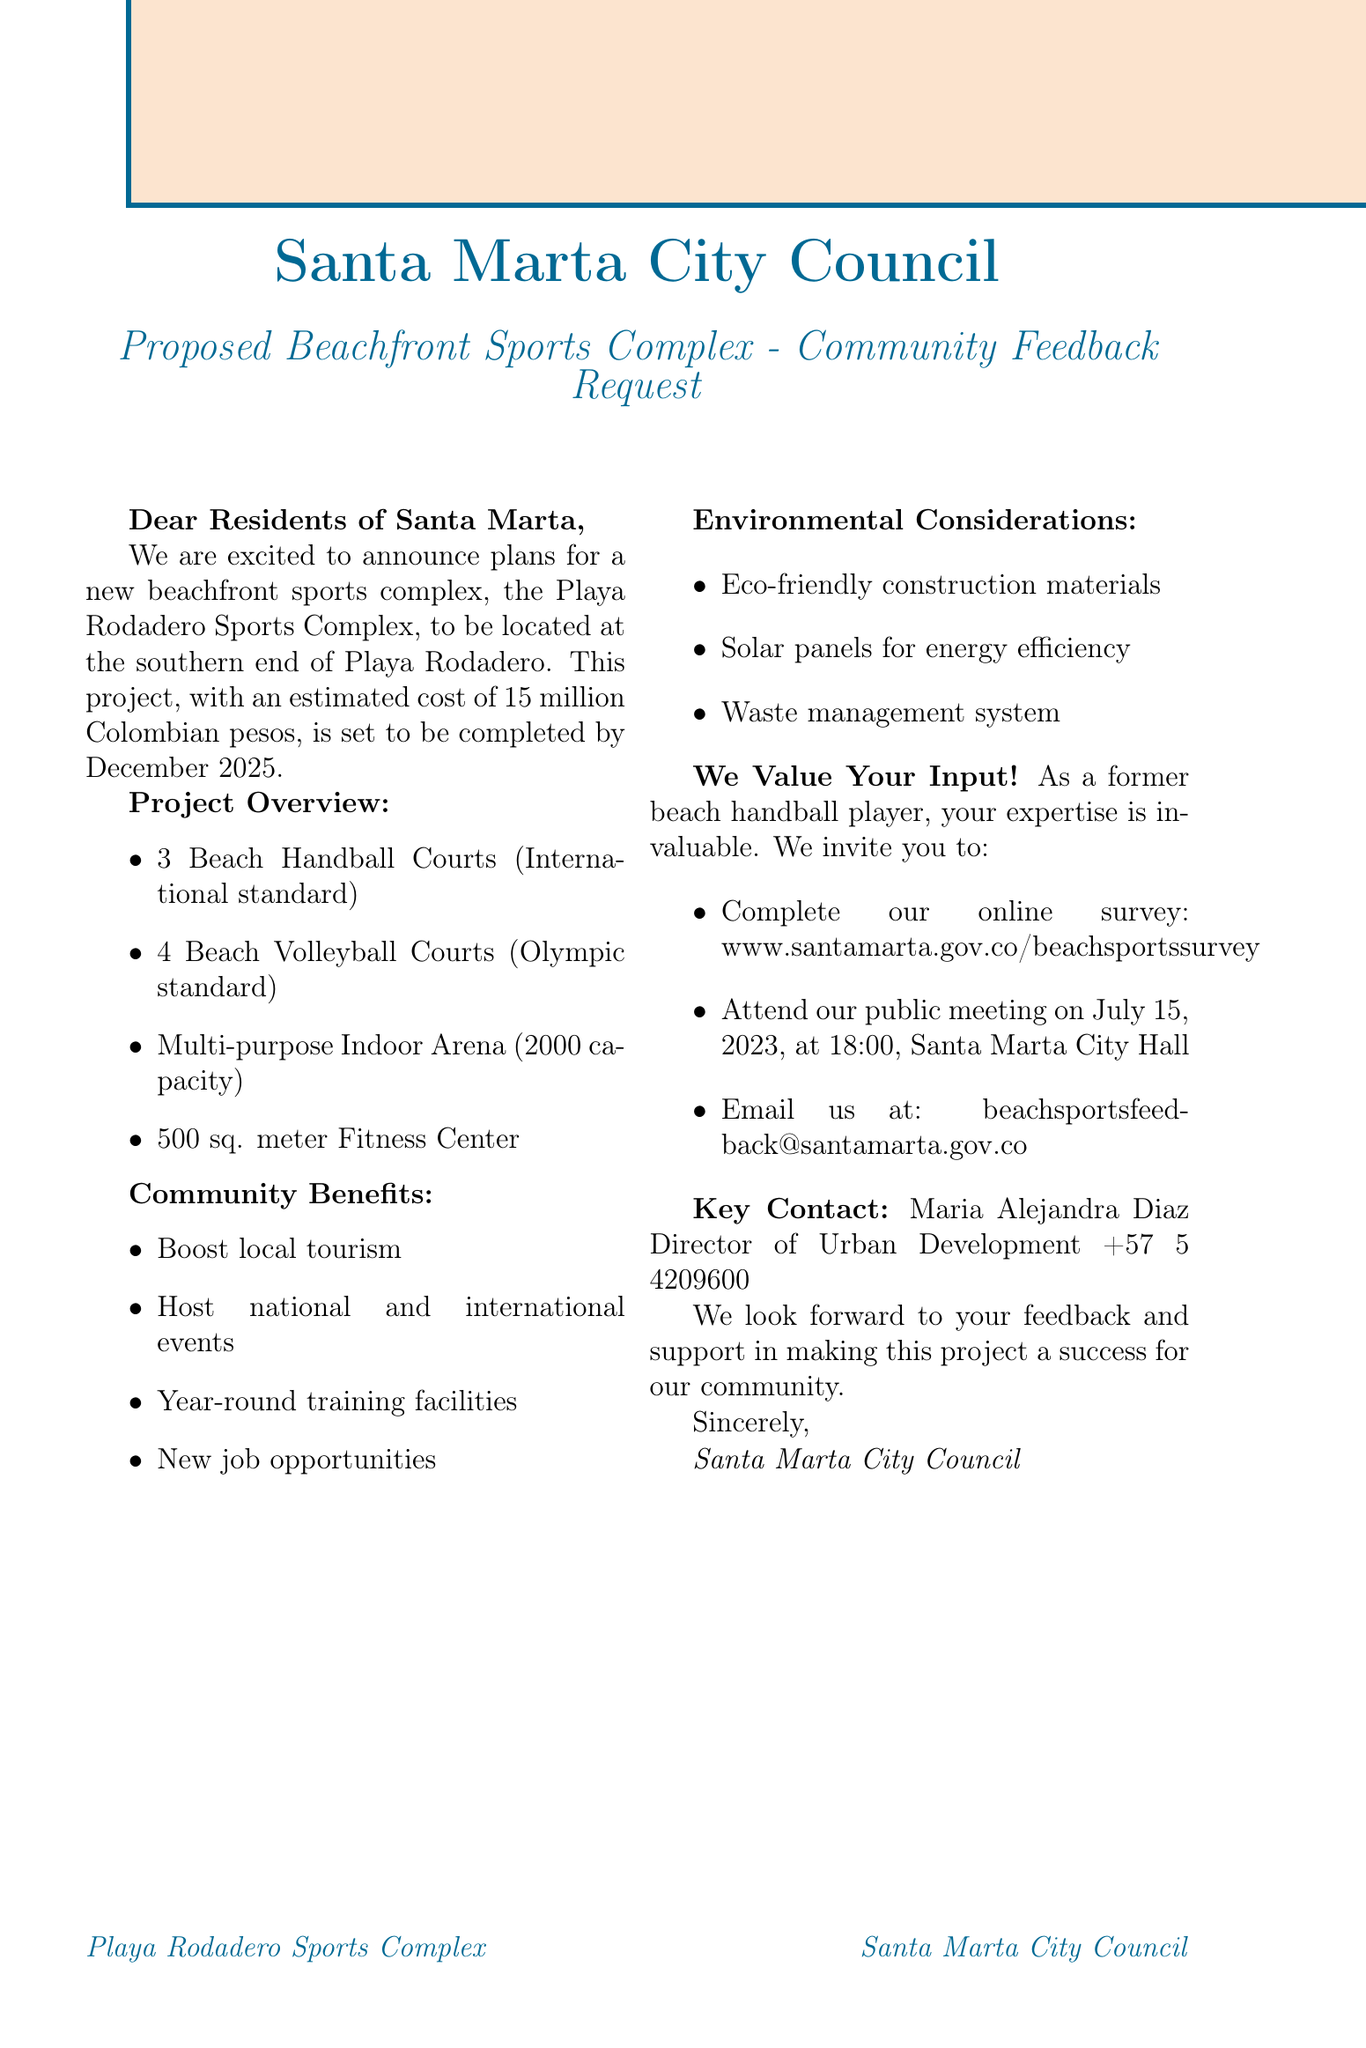What is the name of the proposed sports complex? The name of the proposed sports complex is mentioned in the project overview section of the document.
Answer: Playa Rodadero Sports Complex What is the estimated cost of the project? The estimated cost can be found under the project overview, specifically stated as the cost related to the sports complex.
Answer: 15 million Colombian pesos When is the proposed completion date? The completion date is specified in the project overview section of the letter.
Answer: December 2025 How many beach handball courts are planned? The number of beach handball courts is listed in the facilities section of the document.
Answer: 3 What are two community benefits listed in the document? Community benefits are outlined in a specific section of the document, detailing positive impacts of the sports complex.
Answer: Boost local tourism, Host national and international beach sports events Which materials will be used for construction? The environmental considerations highlight the types of materials that will be used for the construction of the complex.
Answer: Eco-friendly construction materials Who is the key contact person for this project? The key contact person is mentioned in the latter part of the document, along with their title.
Answer: Maria Alejandra Diaz When will the public meeting take place? The public meeting date is provided in the feedback channels section of the letter.
Answer: July 15, 2023 How many sports can the multi-purpose indoor arena accommodate? The document specifies the sports that the multi-purpose indoor arena will host, indicating its varied use.
Answer: Futsal, Basketball, Handball 